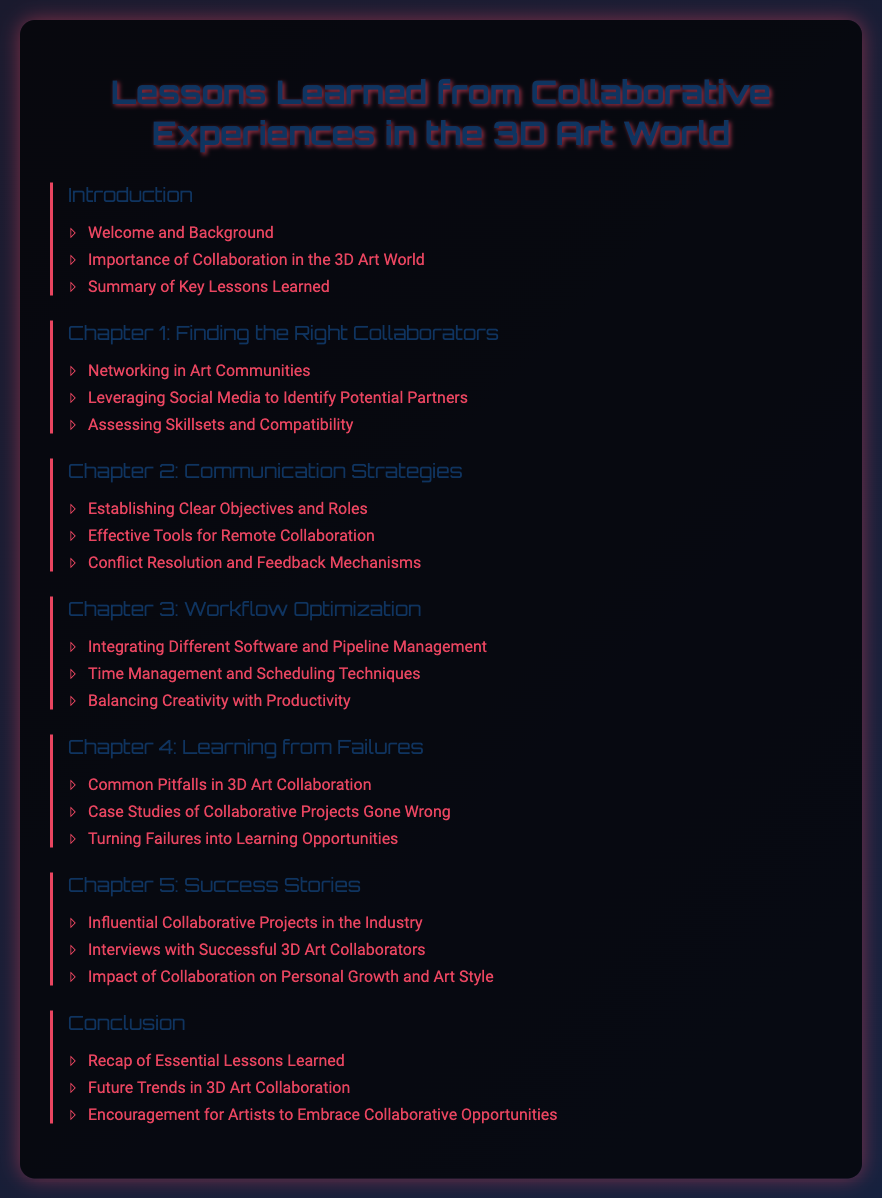What is the title of the document? The title is prominently displayed at the top of the document, defining the main topic covered.
Answer: Lessons Learned from Collaborative Experiences in the 3D Art World What is the first section under the Introduction chapter? The first section listed under the Introduction chapter provides background information on the topic.
Answer: Welcome and Background How many chapters are included in the document? Counting all the listed chapters gives the total number, which is five.
Answer: 5 What is the main focus of Chapter 2? The title of Chapter 2 indicates that it deals with strategies for effective communication in collaborations.
Answer: Communication Strategies Which section discusses handling negative experiences in collaboration? This section focuses on learning from mistakes and establishing a positive takeaway from failures.
Answer: Turning Failures into Learning Opportunities What is encouraged in the Conclusion? The final section under the Conclusion promotes a proactive approach towards new opportunities in collaboration.
Answer: Encouragement for Artists to Embrace Collaborative Opportunities What common theme is addressed in Chapter 4? The chapter discusses shared challenges and learning points experienced in collaborative efforts, particularly when things go wrong.
Answer: Learning from Failures What type of projects are highlighted in Chapter 5? The projects mentioned here are significant collaborations that have had an influential impact on the industry.
Answer: Influential Collaborative Projects in the Industry 